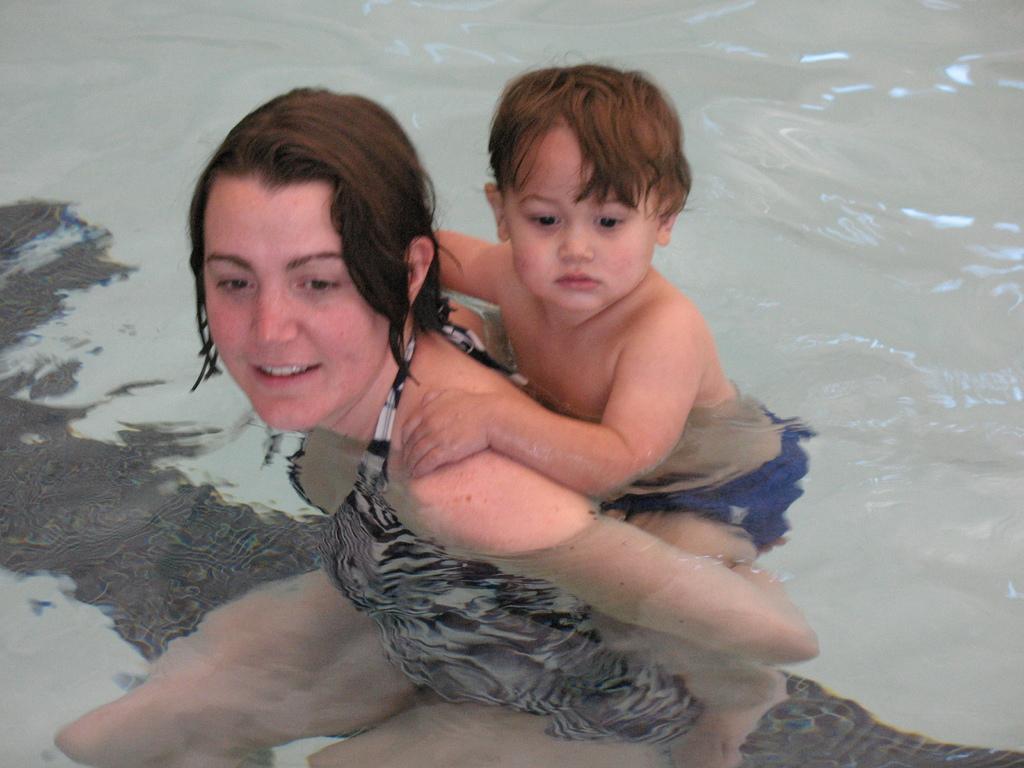In one or two sentences, can you explain what this image depicts? There is one woman and a kid is present in the water as we can see in the middle of this image. 